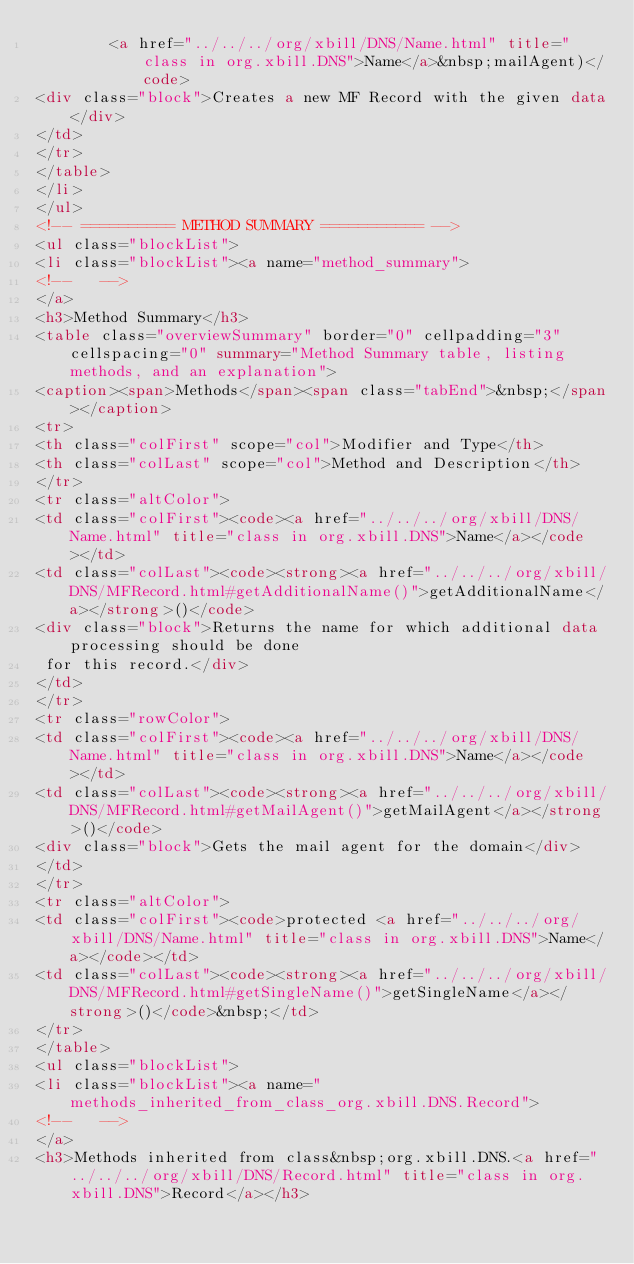<code> <loc_0><loc_0><loc_500><loc_500><_HTML_>        <a href="../../../org/xbill/DNS/Name.html" title="class in org.xbill.DNS">Name</a>&nbsp;mailAgent)</code>
<div class="block">Creates a new MF Record with the given data</div>
</td>
</tr>
</table>
</li>
</ul>
<!-- ========== METHOD SUMMARY =========== -->
<ul class="blockList">
<li class="blockList"><a name="method_summary">
<!--   -->
</a>
<h3>Method Summary</h3>
<table class="overviewSummary" border="0" cellpadding="3" cellspacing="0" summary="Method Summary table, listing methods, and an explanation">
<caption><span>Methods</span><span class="tabEnd">&nbsp;</span></caption>
<tr>
<th class="colFirst" scope="col">Modifier and Type</th>
<th class="colLast" scope="col">Method and Description</th>
</tr>
<tr class="altColor">
<td class="colFirst"><code><a href="../../../org/xbill/DNS/Name.html" title="class in org.xbill.DNS">Name</a></code></td>
<td class="colLast"><code><strong><a href="../../../org/xbill/DNS/MFRecord.html#getAdditionalName()">getAdditionalName</a></strong>()</code>
<div class="block">Returns the name for which additional data processing should be done
 for this record.</div>
</td>
</tr>
<tr class="rowColor">
<td class="colFirst"><code><a href="../../../org/xbill/DNS/Name.html" title="class in org.xbill.DNS">Name</a></code></td>
<td class="colLast"><code><strong><a href="../../../org/xbill/DNS/MFRecord.html#getMailAgent()">getMailAgent</a></strong>()</code>
<div class="block">Gets the mail agent for the domain</div>
</td>
</tr>
<tr class="altColor">
<td class="colFirst"><code>protected <a href="../../../org/xbill/DNS/Name.html" title="class in org.xbill.DNS">Name</a></code></td>
<td class="colLast"><code><strong><a href="../../../org/xbill/DNS/MFRecord.html#getSingleName()">getSingleName</a></strong>()</code>&nbsp;</td>
</tr>
</table>
<ul class="blockList">
<li class="blockList"><a name="methods_inherited_from_class_org.xbill.DNS.Record">
<!--   -->
</a>
<h3>Methods inherited from class&nbsp;org.xbill.DNS.<a href="../../../org/xbill/DNS/Record.html" title="class in org.xbill.DNS">Record</a></h3></code> 